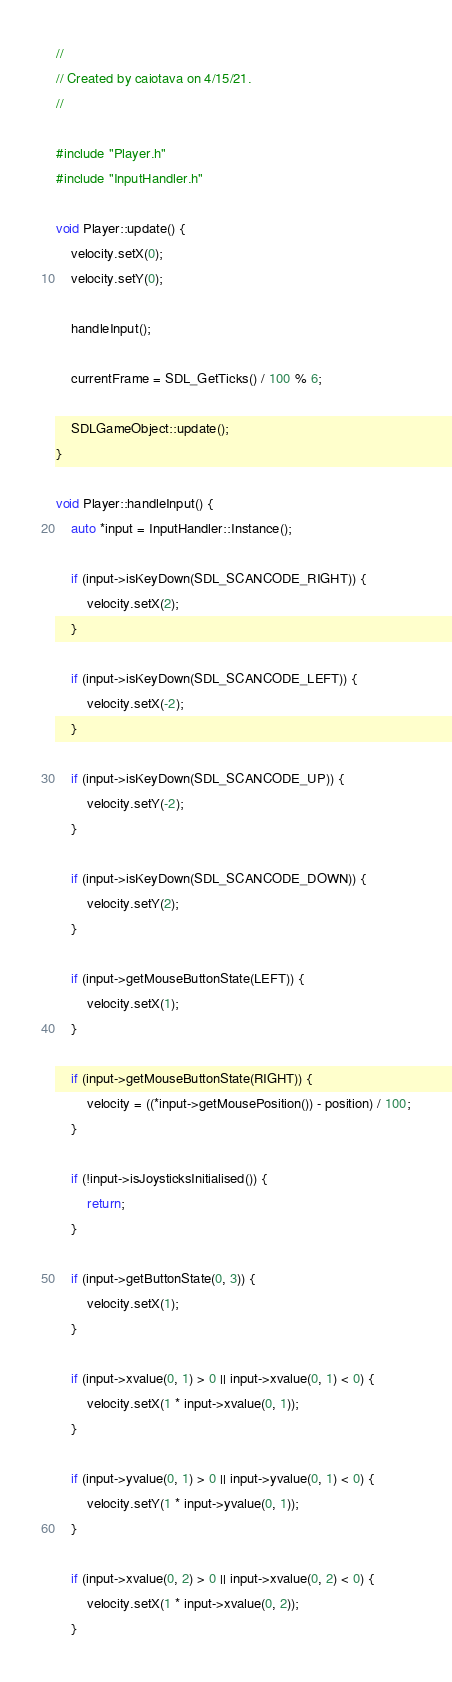Convert code to text. <code><loc_0><loc_0><loc_500><loc_500><_C++_>//
// Created by caiotava on 4/15/21.
//

#include "Player.h"
#include "InputHandler.h"

void Player::update() {
    velocity.setX(0);
    velocity.setY(0);

    handleInput();

    currentFrame = SDL_GetTicks() / 100 % 6;

    SDLGameObject::update();
}

void Player::handleInput() {
    auto *input = InputHandler::Instance();

    if (input->isKeyDown(SDL_SCANCODE_RIGHT)) {
        velocity.setX(2);
    }

    if (input->isKeyDown(SDL_SCANCODE_LEFT)) {
        velocity.setX(-2);
    }

    if (input->isKeyDown(SDL_SCANCODE_UP)) {
        velocity.setY(-2);
    }

    if (input->isKeyDown(SDL_SCANCODE_DOWN)) {
        velocity.setY(2);
    }

    if (input->getMouseButtonState(LEFT)) {
        velocity.setX(1);
    }

    if (input->getMouseButtonState(RIGHT)) {
        velocity = ((*input->getMousePosition()) - position) / 100;
    }

    if (!input->isJoysticksInitialised()) {
        return;
    }

    if (input->getButtonState(0, 3)) {
        velocity.setX(1);
    }

    if (input->xvalue(0, 1) > 0 || input->xvalue(0, 1) < 0) {
        velocity.setX(1 * input->xvalue(0, 1));
    }

    if (input->yvalue(0, 1) > 0 || input->yvalue(0, 1) < 0) {
        velocity.setY(1 * input->yvalue(0, 1));
    }

    if (input->xvalue(0, 2) > 0 || input->xvalue(0, 2) < 0) {
        velocity.setX(1 * input->xvalue(0, 2));
    }
</code> 